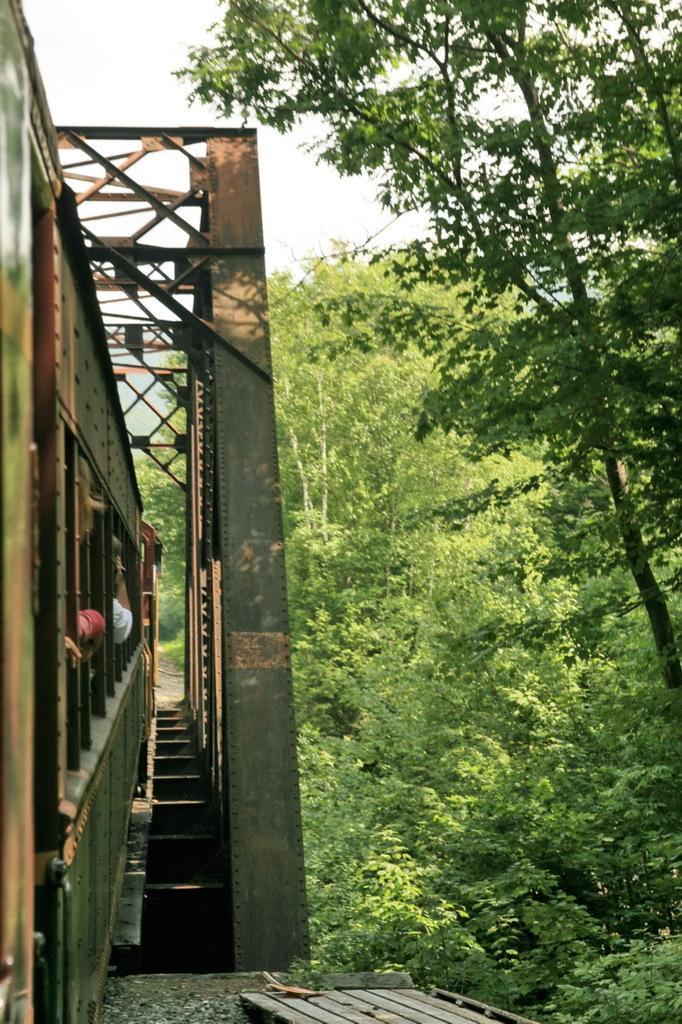Describe this image in one or two sentences. In this image I can see a train on the track. Background I can see trees in green color and the sky is in white color. 